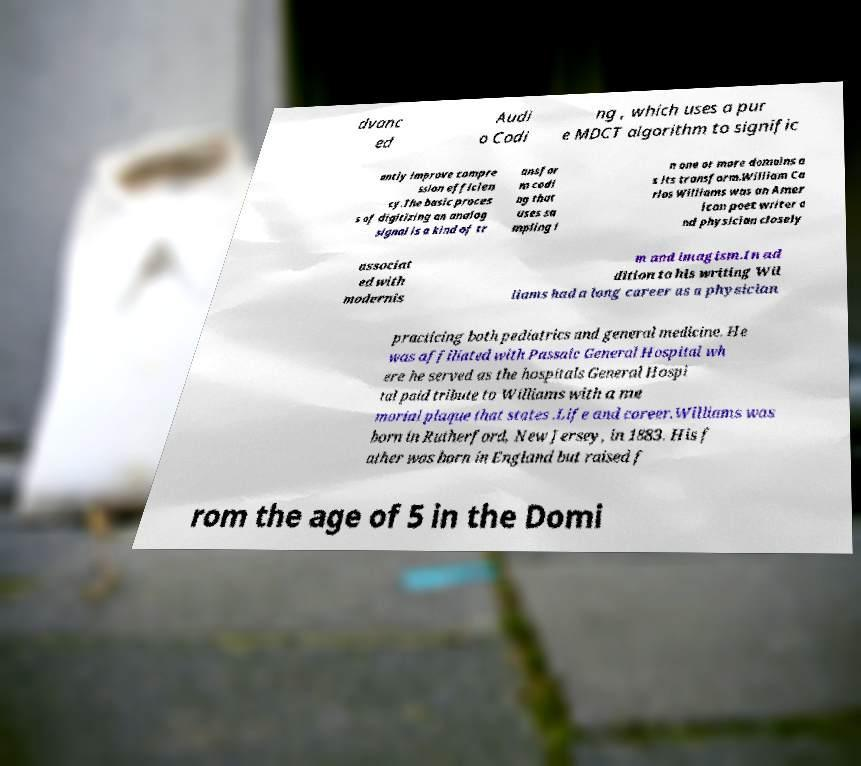Can you read and provide the text displayed in the image?This photo seems to have some interesting text. Can you extract and type it out for me? dvanc ed Audi o Codi ng , which uses a pur e MDCT algorithm to signific antly improve compre ssion efficien cy.The basic proces s of digitizing an analog signal is a kind of tr ansfor m codi ng that uses sa mpling i n one or more domains a s its transform.William Ca rlos Williams was an Amer ican poet writer a nd physician closely associat ed with modernis m and imagism.In ad dition to his writing Wil liams had a long career as a physician practicing both pediatrics and general medicine. He was affiliated with Passaic General Hospital wh ere he served as the hospitals General Hospi tal paid tribute to Williams with a me morial plaque that states .Life and career.Williams was born in Rutherford, New Jersey, in 1883. His f ather was born in England but raised f rom the age of 5 in the Domi 